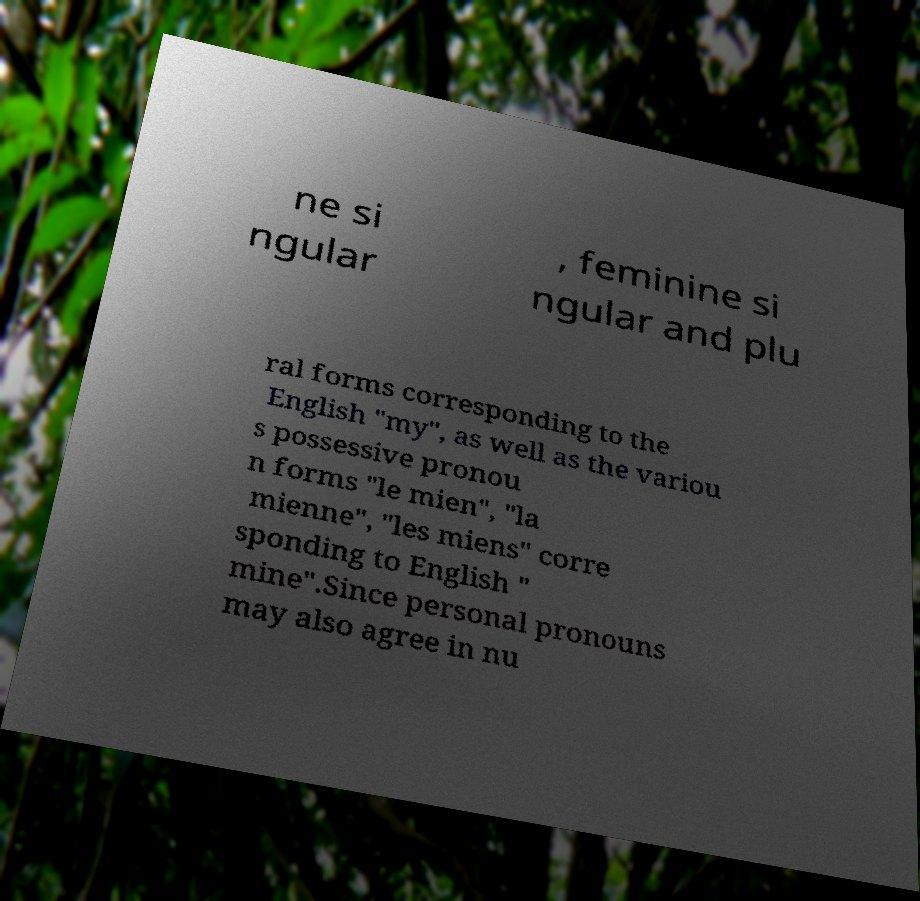Could you assist in decoding the text presented in this image and type it out clearly? ne si ngular , feminine si ngular and plu ral forms corresponding to the English "my", as well as the variou s possessive pronou n forms "le mien", "la mienne", "les miens" corre sponding to English " mine".Since personal pronouns may also agree in nu 